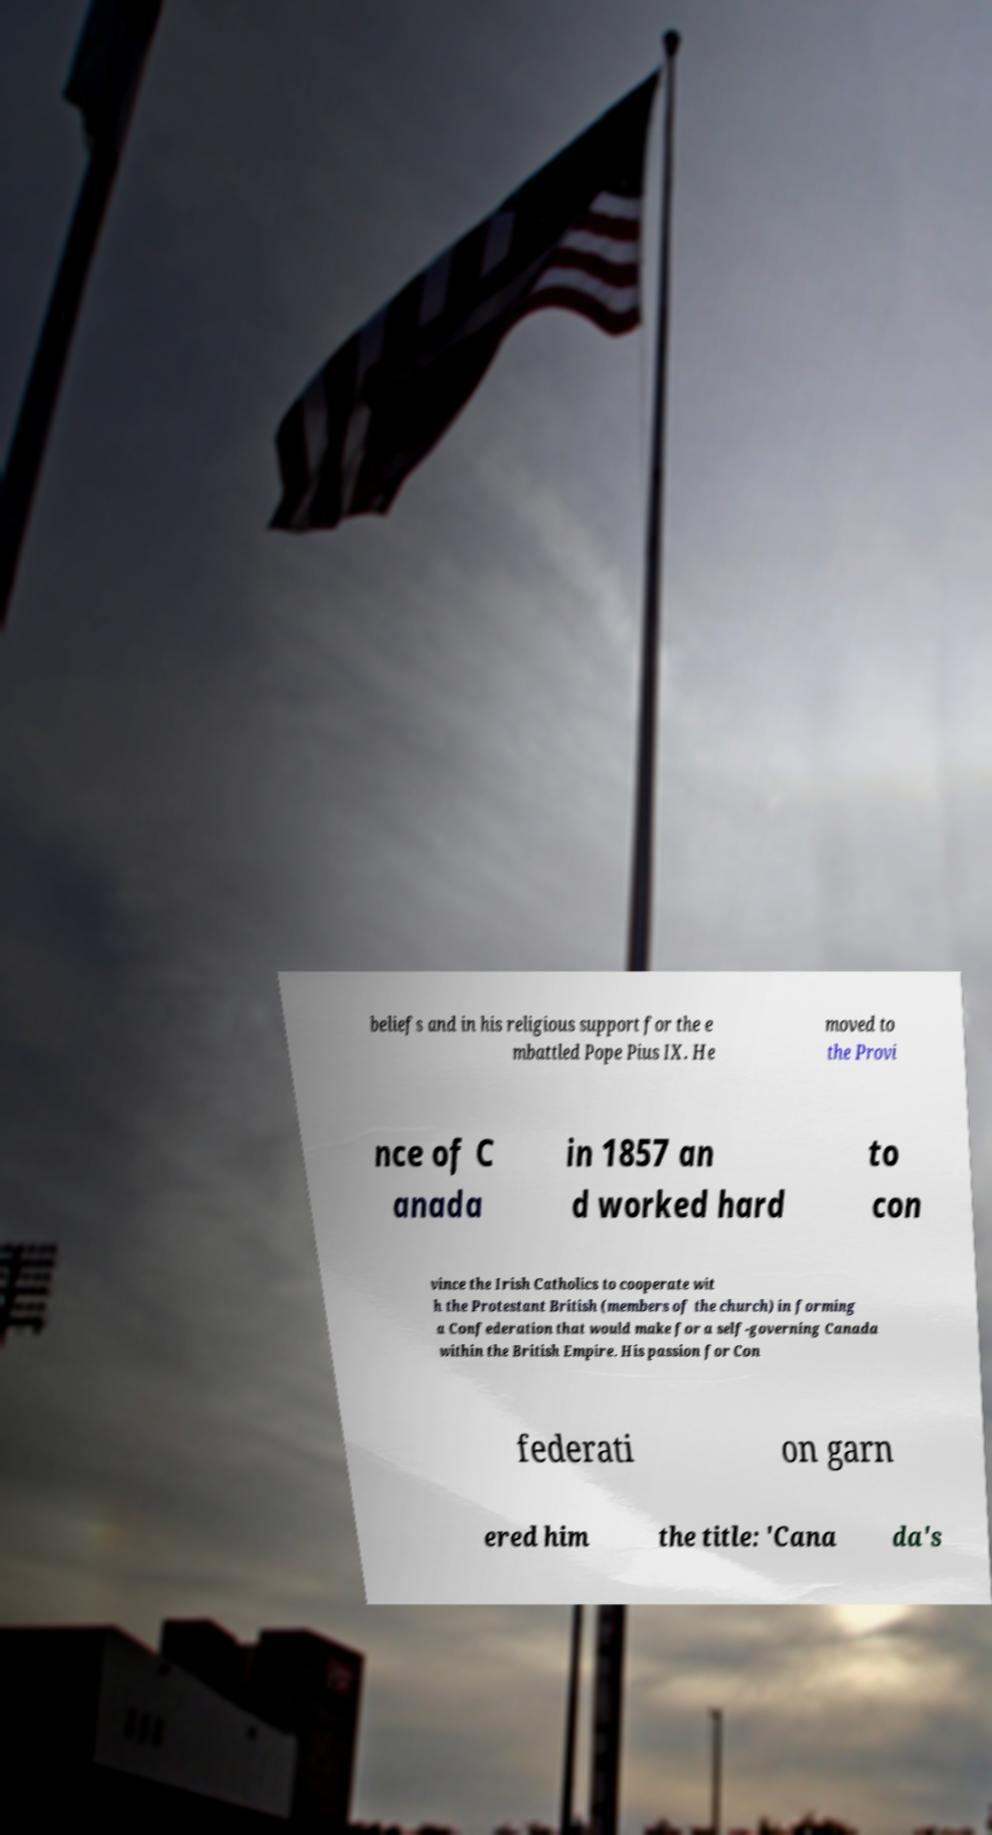Please read and relay the text visible in this image. What does it say? beliefs and in his religious support for the e mbattled Pope Pius IX. He moved to the Provi nce of C anada in 1857 an d worked hard to con vince the Irish Catholics to cooperate wit h the Protestant British (members of the church) in forming a Confederation that would make for a self-governing Canada within the British Empire. His passion for Con federati on garn ered him the title: 'Cana da's 